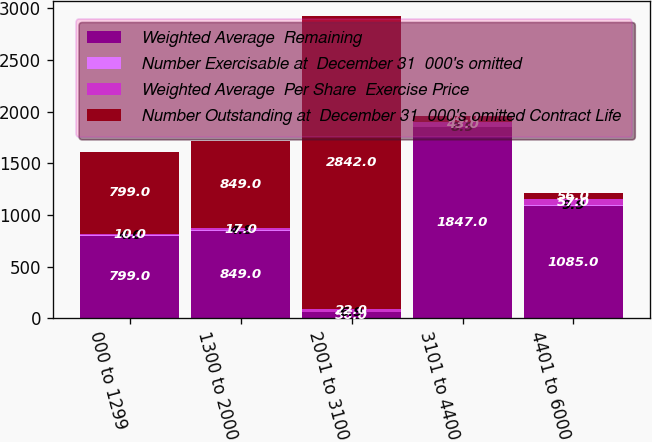<chart> <loc_0><loc_0><loc_500><loc_500><stacked_bar_chart><ecel><fcel>000 to 1299<fcel>1300 to 2000<fcel>2001 to 3100<fcel>3101 to 4400<fcel>4401 to 6000<nl><fcel>Weighted Average  Remaining<fcel>799<fcel>849<fcel>56<fcel>1847<fcel>1085<nl><fcel>Number Exercisable at  December 31  000's omitted<fcel>4<fcel>4.8<fcel>6.9<fcel>8.9<fcel>9.9<nl><fcel>Weighted Average  Per Share  Exercise Price<fcel>10<fcel>17<fcel>22<fcel>43<fcel>57<nl><fcel>Number Outstanding at  December 31  000's omitted Contract Life<fcel>799<fcel>849<fcel>2842<fcel>64<fcel>56<nl></chart> 